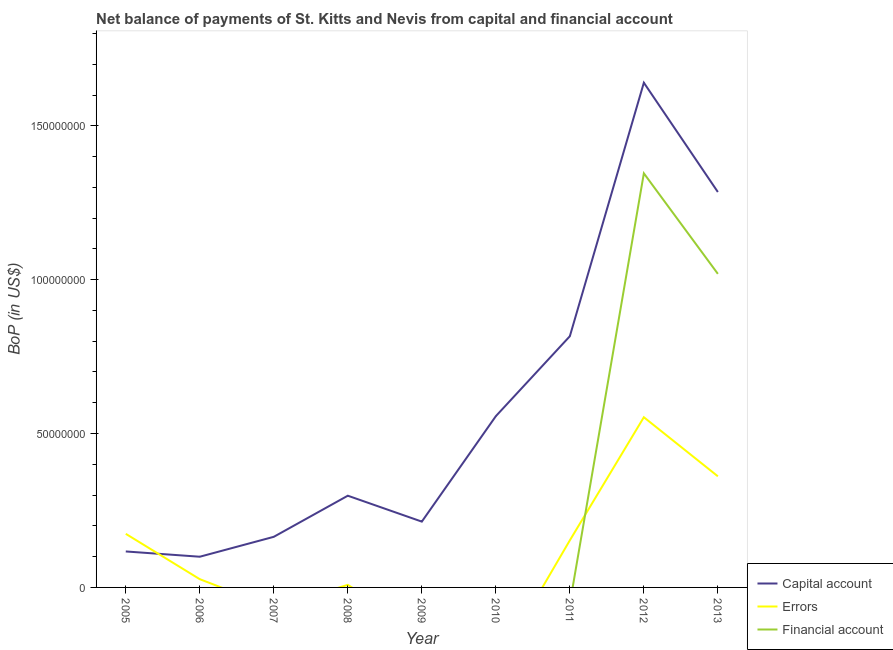Does the line corresponding to amount of financial account intersect with the line corresponding to amount of net capital account?
Your answer should be compact. No. Is the number of lines equal to the number of legend labels?
Ensure brevity in your answer.  No. What is the amount of net capital account in 2011?
Make the answer very short. 8.16e+07. Across all years, what is the maximum amount of errors?
Give a very brief answer. 5.53e+07. Across all years, what is the minimum amount of net capital account?
Provide a succinct answer. 9.98e+06. What is the total amount of financial account in the graph?
Offer a terse response. 2.36e+08. What is the difference between the amount of errors in 2008 and that in 2011?
Offer a terse response. -1.45e+07. What is the difference between the amount of net capital account in 2008 and the amount of errors in 2010?
Keep it short and to the point. 2.98e+07. What is the average amount of financial account per year?
Provide a succinct answer. 2.63e+07. In the year 2006, what is the difference between the amount of net capital account and amount of errors?
Your answer should be compact. 7.30e+06. What is the ratio of the amount of net capital account in 2006 to that in 2008?
Provide a succinct answer. 0.33. Is the amount of errors in 2006 less than that in 2012?
Offer a very short reply. Yes. What is the difference between the highest and the second highest amount of errors?
Give a very brief answer. 1.92e+07. What is the difference between the highest and the lowest amount of errors?
Provide a succinct answer. 5.53e+07. In how many years, is the amount of net capital account greater than the average amount of net capital account taken over all years?
Offer a very short reply. 3. Is the sum of the amount of net capital account in 2008 and 2011 greater than the maximum amount of errors across all years?
Ensure brevity in your answer.  Yes. Is it the case that in every year, the sum of the amount of net capital account and amount of errors is greater than the amount of financial account?
Keep it short and to the point. Yes. Does the amount of errors monotonically increase over the years?
Your answer should be compact. No. Is the amount of financial account strictly greater than the amount of net capital account over the years?
Give a very brief answer. No. Is the amount of errors strictly less than the amount of financial account over the years?
Your answer should be compact. No. How many years are there in the graph?
Your response must be concise. 9. What is the difference between two consecutive major ticks on the Y-axis?
Give a very brief answer. 5.00e+07. Are the values on the major ticks of Y-axis written in scientific E-notation?
Your response must be concise. No. How many legend labels are there?
Your answer should be very brief. 3. How are the legend labels stacked?
Ensure brevity in your answer.  Vertical. What is the title of the graph?
Keep it short and to the point. Net balance of payments of St. Kitts and Nevis from capital and financial account. What is the label or title of the X-axis?
Your answer should be compact. Year. What is the label or title of the Y-axis?
Make the answer very short. BoP (in US$). What is the BoP (in US$) of Capital account in 2005?
Your answer should be very brief. 1.17e+07. What is the BoP (in US$) of Errors in 2005?
Provide a succinct answer. 1.74e+07. What is the BoP (in US$) of Financial account in 2005?
Give a very brief answer. 0. What is the BoP (in US$) in Capital account in 2006?
Provide a succinct answer. 9.98e+06. What is the BoP (in US$) in Errors in 2006?
Keep it short and to the point. 2.68e+06. What is the BoP (in US$) of Financial account in 2006?
Keep it short and to the point. 0. What is the BoP (in US$) of Capital account in 2007?
Your response must be concise. 1.64e+07. What is the BoP (in US$) of Financial account in 2007?
Offer a very short reply. 0. What is the BoP (in US$) of Capital account in 2008?
Offer a very short reply. 2.98e+07. What is the BoP (in US$) in Errors in 2008?
Ensure brevity in your answer.  8.41e+05. What is the BoP (in US$) of Financial account in 2008?
Provide a succinct answer. 0. What is the BoP (in US$) of Capital account in 2009?
Offer a terse response. 2.14e+07. What is the BoP (in US$) in Capital account in 2010?
Give a very brief answer. 5.56e+07. What is the BoP (in US$) of Capital account in 2011?
Provide a short and direct response. 8.16e+07. What is the BoP (in US$) in Errors in 2011?
Keep it short and to the point. 1.53e+07. What is the BoP (in US$) in Financial account in 2011?
Offer a terse response. 0. What is the BoP (in US$) of Capital account in 2012?
Give a very brief answer. 1.64e+08. What is the BoP (in US$) in Errors in 2012?
Give a very brief answer. 5.53e+07. What is the BoP (in US$) of Financial account in 2012?
Offer a terse response. 1.35e+08. What is the BoP (in US$) in Capital account in 2013?
Provide a succinct answer. 1.28e+08. What is the BoP (in US$) in Errors in 2013?
Your response must be concise. 3.61e+07. What is the BoP (in US$) in Financial account in 2013?
Keep it short and to the point. 1.02e+08. Across all years, what is the maximum BoP (in US$) of Capital account?
Your answer should be very brief. 1.64e+08. Across all years, what is the maximum BoP (in US$) of Errors?
Keep it short and to the point. 5.53e+07. Across all years, what is the maximum BoP (in US$) in Financial account?
Offer a terse response. 1.35e+08. Across all years, what is the minimum BoP (in US$) of Capital account?
Ensure brevity in your answer.  9.98e+06. What is the total BoP (in US$) of Capital account in the graph?
Provide a succinct answer. 5.19e+08. What is the total BoP (in US$) in Errors in the graph?
Make the answer very short. 1.28e+08. What is the total BoP (in US$) of Financial account in the graph?
Make the answer very short. 2.36e+08. What is the difference between the BoP (in US$) in Capital account in 2005 and that in 2006?
Your answer should be compact. 1.71e+06. What is the difference between the BoP (in US$) in Errors in 2005 and that in 2006?
Your answer should be very brief. 1.47e+07. What is the difference between the BoP (in US$) of Capital account in 2005 and that in 2007?
Your response must be concise. -4.76e+06. What is the difference between the BoP (in US$) of Capital account in 2005 and that in 2008?
Provide a succinct answer. -1.81e+07. What is the difference between the BoP (in US$) in Errors in 2005 and that in 2008?
Your response must be concise. 1.66e+07. What is the difference between the BoP (in US$) in Capital account in 2005 and that in 2009?
Your answer should be very brief. -9.69e+06. What is the difference between the BoP (in US$) in Capital account in 2005 and that in 2010?
Offer a terse response. -4.40e+07. What is the difference between the BoP (in US$) of Capital account in 2005 and that in 2011?
Your answer should be very brief. -6.99e+07. What is the difference between the BoP (in US$) in Errors in 2005 and that in 2011?
Offer a terse response. 2.11e+06. What is the difference between the BoP (in US$) of Capital account in 2005 and that in 2012?
Provide a short and direct response. -1.52e+08. What is the difference between the BoP (in US$) of Errors in 2005 and that in 2012?
Provide a succinct answer. -3.79e+07. What is the difference between the BoP (in US$) in Capital account in 2005 and that in 2013?
Give a very brief answer. -1.17e+08. What is the difference between the BoP (in US$) of Errors in 2005 and that in 2013?
Ensure brevity in your answer.  -1.87e+07. What is the difference between the BoP (in US$) in Capital account in 2006 and that in 2007?
Your response must be concise. -6.47e+06. What is the difference between the BoP (in US$) of Capital account in 2006 and that in 2008?
Provide a succinct answer. -1.98e+07. What is the difference between the BoP (in US$) of Errors in 2006 and that in 2008?
Your response must be concise. 1.84e+06. What is the difference between the BoP (in US$) in Capital account in 2006 and that in 2009?
Provide a short and direct response. -1.14e+07. What is the difference between the BoP (in US$) in Capital account in 2006 and that in 2010?
Your answer should be very brief. -4.57e+07. What is the difference between the BoP (in US$) in Capital account in 2006 and that in 2011?
Keep it short and to the point. -7.16e+07. What is the difference between the BoP (in US$) of Errors in 2006 and that in 2011?
Give a very brief answer. -1.26e+07. What is the difference between the BoP (in US$) of Capital account in 2006 and that in 2012?
Give a very brief answer. -1.54e+08. What is the difference between the BoP (in US$) in Errors in 2006 and that in 2012?
Make the answer very short. -5.26e+07. What is the difference between the BoP (in US$) of Capital account in 2006 and that in 2013?
Ensure brevity in your answer.  -1.19e+08. What is the difference between the BoP (in US$) of Errors in 2006 and that in 2013?
Ensure brevity in your answer.  -3.34e+07. What is the difference between the BoP (in US$) of Capital account in 2007 and that in 2008?
Make the answer very short. -1.34e+07. What is the difference between the BoP (in US$) in Capital account in 2007 and that in 2009?
Provide a short and direct response. -4.94e+06. What is the difference between the BoP (in US$) in Capital account in 2007 and that in 2010?
Provide a short and direct response. -3.92e+07. What is the difference between the BoP (in US$) in Capital account in 2007 and that in 2011?
Provide a short and direct response. -6.52e+07. What is the difference between the BoP (in US$) of Capital account in 2007 and that in 2012?
Your answer should be very brief. -1.48e+08. What is the difference between the BoP (in US$) of Capital account in 2007 and that in 2013?
Offer a terse response. -1.12e+08. What is the difference between the BoP (in US$) of Capital account in 2008 and that in 2009?
Your answer should be compact. 8.42e+06. What is the difference between the BoP (in US$) of Capital account in 2008 and that in 2010?
Give a very brief answer. -2.58e+07. What is the difference between the BoP (in US$) in Capital account in 2008 and that in 2011?
Ensure brevity in your answer.  -5.18e+07. What is the difference between the BoP (in US$) in Errors in 2008 and that in 2011?
Your answer should be very brief. -1.45e+07. What is the difference between the BoP (in US$) in Capital account in 2008 and that in 2012?
Make the answer very short. -1.34e+08. What is the difference between the BoP (in US$) in Errors in 2008 and that in 2012?
Provide a succinct answer. -5.45e+07. What is the difference between the BoP (in US$) of Capital account in 2008 and that in 2013?
Keep it short and to the point. -9.87e+07. What is the difference between the BoP (in US$) in Errors in 2008 and that in 2013?
Your answer should be very brief. -3.53e+07. What is the difference between the BoP (in US$) in Capital account in 2009 and that in 2010?
Offer a terse response. -3.43e+07. What is the difference between the BoP (in US$) of Capital account in 2009 and that in 2011?
Offer a very short reply. -6.02e+07. What is the difference between the BoP (in US$) in Capital account in 2009 and that in 2012?
Offer a terse response. -1.43e+08. What is the difference between the BoP (in US$) of Capital account in 2009 and that in 2013?
Provide a succinct answer. -1.07e+08. What is the difference between the BoP (in US$) in Capital account in 2010 and that in 2011?
Keep it short and to the point. -2.60e+07. What is the difference between the BoP (in US$) of Capital account in 2010 and that in 2012?
Offer a very short reply. -1.08e+08. What is the difference between the BoP (in US$) in Capital account in 2010 and that in 2013?
Offer a terse response. -7.28e+07. What is the difference between the BoP (in US$) of Capital account in 2011 and that in 2012?
Provide a succinct answer. -8.24e+07. What is the difference between the BoP (in US$) in Errors in 2011 and that in 2012?
Keep it short and to the point. -4.00e+07. What is the difference between the BoP (in US$) in Capital account in 2011 and that in 2013?
Your answer should be compact. -4.69e+07. What is the difference between the BoP (in US$) of Errors in 2011 and that in 2013?
Your answer should be very brief. -2.08e+07. What is the difference between the BoP (in US$) of Capital account in 2012 and that in 2013?
Provide a succinct answer. 3.55e+07. What is the difference between the BoP (in US$) in Errors in 2012 and that in 2013?
Make the answer very short. 1.92e+07. What is the difference between the BoP (in US$) in Financial account in 2012 and that in 2013?
Your answer should be compact. 3.27e+07. What is the difference between the BoP (in US$) of Capital account in 2005 and the BoP (in US$) of Errors in 2006?
Offer a terse response. 9.01e+06. What is the difference between the BoP (in US$) in Capital account in 2005 and the BoP (in US$) in Errors in 2008?
Keep it short and to the point. 1.08e+07. What is the difference between the BoP (in US$) of Capital account in 2005 and the BoP (in US$) of Errors in 2011?
Offer a terse response. -3.61e+06. What is the difference between the BoP (in US$) of Capital account in 2005 and the BoP (in US$) of Errors in 2012?
Your answer should be compact. -4.36e+07. What is the difference between the BoP (in US$) in Capital account in 2005 and the BoP (in US$) in Financial account in 2012?
Provide a succinct answer. -1.23e+08. What is the difference between the BoP (in US$) in Errors in 2005 and the BoP (in US$) in Financial account in 2012?
Provide a succinct answer. -1.17e+08. What is the difference between the BoP (in US$) in Capital account in 2005 and the BoP (in US$) in Errors in 2013?
Your answer should be compact. -2.44e+07. What is the difference between the BoP (in US$) in Capital account in 2005 and the BoP (in US$) in Financial account in 2013?
Your answer should be very brief. -9.02e+07. What is the difference between the BoP (in US$) of Errors in 2005 and the BoP (in US$) of Financial account in 2013?
Give a very brief answer. -8.45e+07. What is the difference between the BoP (in US$) in Capital account in 2006 and the BoP (in US$) in Errors in 2008?
Your answer should be very brief. 9.13e+06. What is the difference between the BoP (in US$) in Capital account in 2006 and the BoP (in US$) in Errors in 2011?
Ensure brevity in your answer.  -5.33e+06. What is the difference between the BoP (in US$) of Capital account in 2006 and the BoP (in US$) of Errors in 2012?
Provide a short and direct response. -4.53e+07. What is the difference between the BoP (in US$) in Capital account in 2006 and the BoP (in US$) in Financial account in 2012?
Provide a succinct answer. -1.25e+08. What is the difference between the BoP (in US$) of Errors in 2006 and the BoP (in US$) of Financial account in 2012?
Provide a succinct answer. -1.32e+08. What is the difference between the BoP (in US$) of Capital account in 2006 and the BoP (in US$) of Errors in 2013?
Offer a terse response. -2.61e+07. What is the difference between the BoP (in US$) of Capital account in 2006 and the BoP (in US$) of Financial account in 2013?
Ensure brevity in your answer.  -9.19e+07. What is the difference between the BoP (in US$) of Errors in 2006 and the BoP (in US$) of Financial account in 2013?
Keep it short and to the point. -9.92e+07. What is the difference between the BoP (in US$) in Capital account in 2007 and the BoP (in US$) in Errors in 2008?
Keep it short and to the point. 1.56e+07. What is the difference between the BoP (in US$) in Capital account in 2007 and the BoP (in US$) in Errors in 2011?
Offer a terse response. 1.14e+06. What is the difference between the BoP (in US$) in Capital account in 2007 and the BoP (in US$) in Errors in 2012?
Your answer should be compact. -3.89e+07. What is the difference between the BoP (in US$) in Capital account in 2007 and the BoP (in US$) in Financial account in 2012?
Your answer should be compact. -1.18e+08. What is the difference between the BoP (in US$) of Capital account in 2007 and the BoP (in US$) of Errors in 2013?
Provide a short and direct response. -1.97e+07. What is the difference between the BoP (in US$) of Capital account in 2007 and the BoP (in US$) of Financial account in 2013?
Make the answer very short. -8.54e+07. What is the difference between the BoP (in US$) of Capital account in 2008 and the BoP (in US$) of Errors in 2011?
Your answer should be compact. 1.45e+07. What is the difference between the BoP (in US$) in Capital account in 2008 and the BoP (in US$) in Errors in 2012?
Your answer should be compact. -2.55e+07. What is the difference between the BoP (in US$) of Capital account in 2008 and the BoP (in US$) of Financial account in 2012?
Provide a succinct answer. -1.05e+08. What is the difference between the BoP (in US$) of Errors in 2008 and the BoP (in US$) of Financial account in 2012?
Your response must be concise. -1.34e+08. What is the difference between the BoP (in US$) of Capital account in 2008 and the BoP (in US$) of Errors in 2013?
Ensure brevity in your answer.  -6.31e+06. What is the difference between the BoP (in US$) of Capital account in 2008 and the BoP (in US$) of Financial account in 2013?
Make the answer very short. -7.21e+07. What is the difference between the BoP (in US$) in Errors in 2008 and the BoP (in US$) in Financial account in 2013?
Offer a very short reply. -1.01e+08. What is the difference between the BoP (in US$) in Capital account in 2009 and the BoP (in US$) in Errors in 2011?
Give a very brief answer. 6.08e+06. What is the difference between the BoP (in US$) in Capital account in 2009 and the BoP (in US$) in Errors in 2012?
Offer a terse response. -3.39e+07. What is the difference between the BoP (in US$) of Capital account in 2009 and the BoP (in US$) of Financial account in 2012?
Your answer should be very brief. -1.13e+08. What is the difference between the BoP (in US$) in Capital account in 2009 and the BoP (in US$) in Errors in 2013?
Ensure brevity in your answer.  -1.47e+07. What is the difference between the BoP (in US$) in Capital account in 2009 and the BoP (in US$) in Financial account in 2013?
Give a very brief answer. -8.05e+07. What is the difference between the BoP (in US$) in Capital account in 2010 and the BoP (in US$) in Errors in 2011?
Make the answer very short. 4.03e+07. What is the difference between the BoP (in US$) in Capital account in 2010 and the BoP (in US$) in Errors in 2012?
Make the answer very short. 3.44e+05. What is the difference between the BoP (in US$) of Capital account in 2010 and the BoP (in US$) of Financial account in 2012?
Your answer should be compact. -7.89e+07. What is the difference between the BoP (in US$) of Capital account in 2010 and the BoP (in US$) of Errors in 2013?
Provide a short and direct response. 1.95e+07. What is the difference between the BoP (in US$) in Capital account in 2010 and the BoP (in US$) in Financial account in 2013?
Give a very brief answer. -4.62e+07. What is the difference between the BoP (in US$) in Capital account in 2011 and the BoP (in US$) in Errors in 2012?
Provide a succinct answer. 2.63e+07. What is the difference between the BoP (in US$) in Capital account in 2011 and the BoP (in US$) in Financial account in 2012?
Keep it short and to the point. -5.29e+07. What is the difference between the BoP (in US$) of Errors in 2011 and the BoP (in US$) of Financial account in 2012?
Offer a terse response. -1.19e+08. What is the difference between the BoP (in US$) in Capital account in 2011 and the BoP (in US$) in Errors in 2013?
Provide a succinct answer. 4.55e+07. What is the difference between the BoP (in US$) in Capital account in 2011 and the BoP (in US$) in Financial account in 2013?
Give a very brief answer. -2.03e+07. What is the difference between the BoP (in US$) in Errors in 2011 and the BoP (in US$) in Financial account in 2013?
Keep it short and to the point. -8.66e+07. What is the difference between the BoP (in US$) of Capital account in 2012 and the BoP (in US$) of Errors in 2013?
Ensure brevity in your answer.  1.28e+08. What is the difference between the BoP (in US$) of Capital account in 2012 and the BoP (in US$) of Financial account in 2013?
Give a very brief answer. 6.21e+07. What is the difference between the BoP (in US$) of Errors in 2012 and the BoP (in US$) of Financial account in 2013?
Your answer should be compact. -4.66e+07. What is the average BoP (in US$) of Capital account per year?
Provide a short and direct response. 5.77e+07. What is the average BoP (in US$) in Errors per year?
Provide a succinct answer. 1.42e+07. What is the average BoP (in US$) of Financial account per year?
Ensure brevity in your answer.  2.63e+07. In the year 2005, what is the difference between the BoP (in US$) in Capital account and BoP (in US$) in Errors?
Provide a short and direct response. -5.73e+06. In the year 2006, what is the difference between the BoP (in US$) of Capital account and BoP (in US$) of Errors?
Give a very brief answer. 7.30e+06. In the year 2008, what is the difference between the BoP (in US$) of Capital account and BoP (in US$) of Errors?
Your answer should be compact. 2.90e+07. In the year 2011, what is the difference between the BoP (in US$) in Capital account and BoP (in US$) in Errors?
Your answer should be compact. 6.63e+07. In the year 2012, what is the difference between the BoP (in US$) in Capital account and BoP (in US$) in Errors?
Provide a short and direct response. 1.09e+08. In the year 2012, what is the difference between the BoP (in US$) of Capital account and BoP (in US$) of Financial account?
Your answer should be compact. 2.94e+07. In the year 2012, what is the difference between the BoP (in US$) in Errors and BoP (in US$) in Financial account?
Offer a very short reply. -7.93e+07. In the year 2013, what is the difference between the BoP (in US$) in Capital account and BoP (in US$) in Errors?
Make the answer very short. 9.24e+07. In the year 2013, what is the difference between the BoP (in US$) of Capital account and BoP (in US$) of Financial account?
Your answer should be very brief. 2.66e+07. In the year 2013, what is the difference between the BoP (in US$) in Errors and BoP (in US$) in Financial account?
Offer a terse response. -6.58e+07. What is the ratio of the BoP (in US$) of Capital account in 2005 to that in 2006?
Offer a very short reply. 1.17. What is the ratio of the BoP (in US$) of Errors in 2005 to that in 2006?
Your answer should be very brief. 6.51. What is the ratio of the BoP (in US$) of Capital account in 2005 to that in 2007?
Make the answer very short. 0.71. What is the ratio of the BoP (in US$) of Capital account in 2005 to that in 2008?
Make the answer very short. 0.39. What is the ratio of the BoP (in US$) of Errors in 2005 to that in 2008?
Make the answer very short. 20.72. What is the ratio of the BoP (in US$) of Capital account in 2005 to that in 2009?
Make the answer very short. 0.55. What is the ratio of the BoP (in US$) in Capital account in 2005 to that in 2010?
Provide a succinct answer. 0.21. What is the ratio of the BoP (in US$) in Capital account in 2005 to that in 2011?
Your response must be concise. 0.14. What is the ratio of the BoP (in US$) of Errors in 2005 to that in 2011?
Ensure brevity in your answer.  1.14. What is the ratio of the BoP (in US$) of Capital account in 2005 to that in 2012?
Your response must be concise. 0.07. What is the ratio of the BoP (in US$) in Errors in 2005 to that in 2012?
Your response must be concise. 0.32. What is the ratio of the BoP (in US$) of Capital account in 2005 to that in 2013?
Offer a terse response. 0.09. What is the ratio of the BoP (in US$) in Errors in 2005 to that in 2013?
Give a very brief answer. 0.48. What is the ratio of the BoP (in US$) in Capital account in 2006 to that in 2007?
Make the answer very short. 0.61. What is the ratio of the BoP (in US$) in Capital account in 2006 to that in 2008?
Your answer should be very brief. 0.33. What is the ratio of the BoP (in US$) in Errors in 2006 to that in 2008?
Provide a short and direct response. 3.18. What is the ratio of the BoP (in US$) of Capital account in 2006 to that in 2009?
Your answer should be compact. 0.47. What is the ratio of the BoP (in US$) of Capital account in 2006 to that in 2010?
Offer a very short reply. 0.18. What is the ratio of the BoP (in US$) in Capital account in 2006 to that in 2011?
Your answer should be very brief. 0.12. What is the ratio of the BoP (in US$) in Errors in 2006 to that in 2011?
Provide a succinct answer. 0.17. What is the ratio of the BoP (in US$) in Capital account in 2006 to that in 2012?
Your answer should be very brief. 0.06. What is the ratio of the BoP (in US$) in Errors in 2006 to that in 2012?
Offer a very short reply. 0.05. What is the ratio of the BoP (in US$) in Capital account in 2006 to that in 2013?
Offer a terse response. 0.08. What is the ratio of the BoP (in US$) of Errors in 2006 to that in 2013?
Ensure brevity in your answer.  0.07. What is the ratio of the BoP (in US$) of Capital account in 2007 to that in 2008?
Your answer should be compact. 0.55. What is the ratio of the BoP (in US$) in Capital account in 2007 to that in 2009?
Your answer should be compact. 0.77. What is the ratio of the BoP (in US$) of Capital account in 2007 to that in 2010?
Make the answer very short. 0.3. What is the ratio of the BoP (in US$) in Capital account in 2007 to that in 2011?
Give a very brief answer. 0.2. What is the ratio of the BoP (in US$) of Capital account in 2007 to that in 2012?
Provide a short and direct response. 0.1. What is the ratio of the BoP (in US$) of Capital account in 2007 to that in 2013?
Offer a terse response. 0.13. What is the ratio of the BoP (in US$) in Capital account in 2008 to that in 2009?
Give a very brief answer. 1.39. What is the ratio of the BoP (in US$) of Capital account in 2008 to that in 2010?
Keep it short and to the point. 0.54. What is the ratio of the BoP (in US$) of Capital account in 2008 to that in 2011?
Offer a very short reply. 0.37. What is the ratio of the BoP (in US$) of Errors in 2008 to that in 2011?
Offer a very short reply. 0.05. What is the ratio of the BoP (in US$) in Capital account in 2008 to that in 2012?
Make the answer very short. 0.18. What is the ratio of the BoP (in US$) of Errors in 2008 to that in 2012?
Provide a succinct answer. 0.02. What is the ratio of the BoP (in US$) in Capital account in 2008 to that in 2013?
Make the answer very short. 0.23. What is the ratio of the BoP (in US$) in Errors in 2008 to that in 2013?
Your answer should be compact. 0.02. What is the ratio of the BoP (in US$) in Capital account in 2009 to that in 2010?
Your answer should be compact. 0.38. What is the ratio of the BoP (in US$) in Capital account in 2009 to that in 2011?
Your answer should be compact. 0.26. What is the ratio of the BoP (in US$) of Capital account in 2009 to that in 2012?
Provide a succinct answer. 0.13. What is the ratio of the BoP (in US$) of Capital account in 2009 to that in 2013?
Give a very brief answer. 0.17. What is the ratio of the BoP (in US$) of Capital account in 2010 to that in 2011?
Make the answer very short. 0.68. What is the ratio of the BoP (in US$) of Capital account in 2010 to that in 2012?
Your answer should be very brief. 0.34. What is the ratio of the BoP (in US$) in Capital account in 2010 to that in 2013?
Keep it short and to the point. 0.43. What is the ratio of the BoP (in US$) in Capital account in 2011 to that in 2012?
Provide a short and direct response. 0.5. What is the ratio of the BoP (in US$) in Errors in 2011 to that in 2012?
Keep it short and to the point. 0.28. What is the ratio of the BoP (in US$) in Capital account in 2011 to that in 2013?
Your answer should be compact. 0.64. What is the ratio of the BoP (in US$) in Errors in 2011 to that in 2013?
Provide a short and direct response. 0.42. What is the ratio of the BoP (in US$) of Capital account in 2012 to that in 2013?
Your answer should be compact. 1.28. What is the ratio of the BoP (in US$) of Errors in 2012 to that in 2013?
Give a very brief answer. 1.53. What is the ratio of the BoP (in US$) of Financial account in 2012 to that in 2013?
Your response must be concise. 1.32. What is the difference between the highest and the second highest BoP (in US$) of Capital account?
Offer a very short reply. 3.55e+07. What is the difference between the highest and the second highest BoP (in US$) of Errors?
Ensure brevity in your answer.  1.92e+07. What is the difference between the highest and the lowest BoP (in US$) in Capital account?
Give a very brief answer. 1.54e+08. What is the difference between the highest and the lowest BoP (in US$) in Errors?
Your answer should be compact. 5.53e+07. What is the difference between the highest and the lowest BoP (in US$) of Financial account?
Keep it short and to the point. 1.35e+08. 